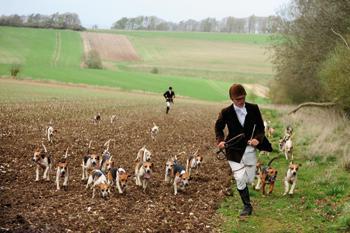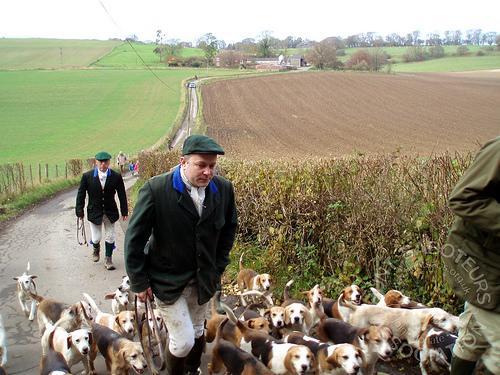The first image is the image on the left, the second image is the image on the right. Given the left and right images, does the statement "There is no more than one human in the right image." hold true? Answer yes or no. No. 